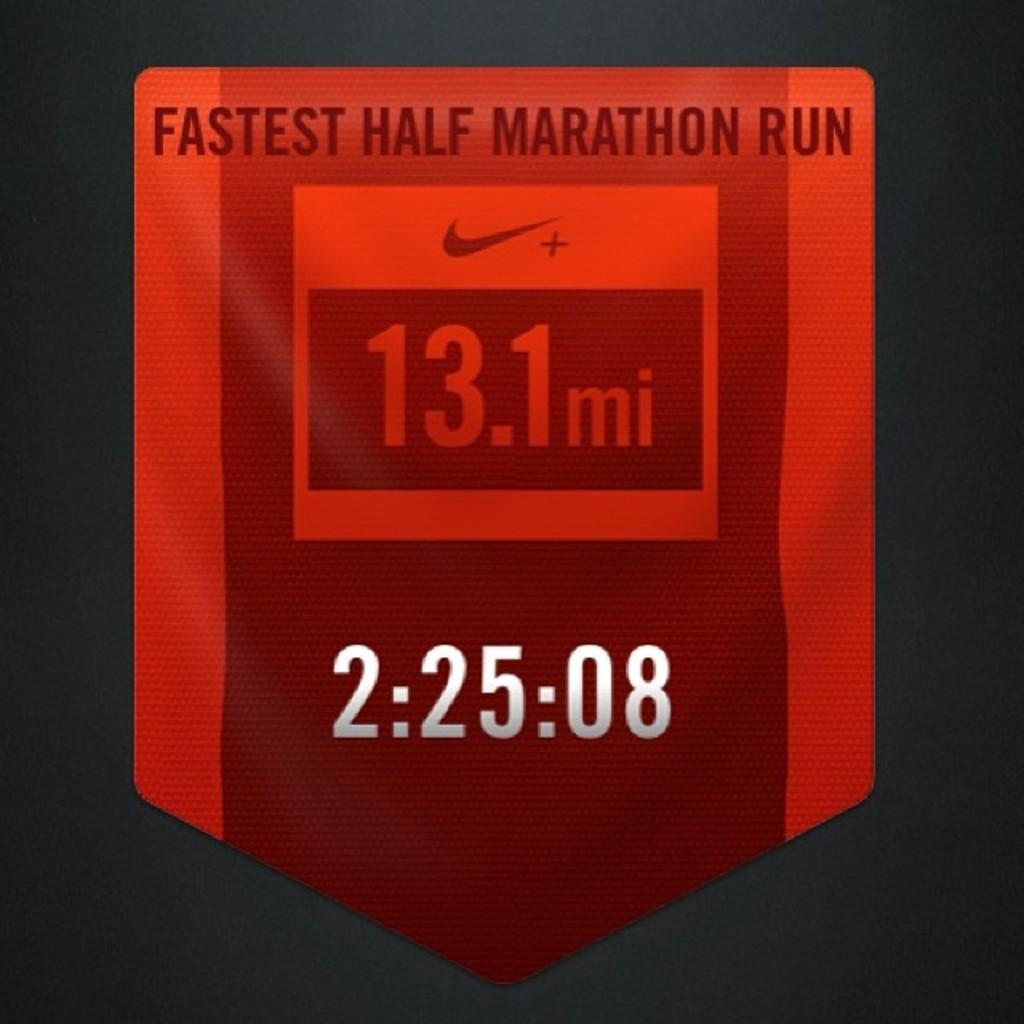<image>
Provide a brief description of the given image. Red symbol showing the fastest half marathon run which was at 13.1 mi. 